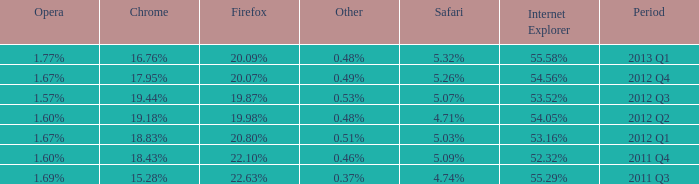What safari has 2012 q4 as the period? 5.26%. 